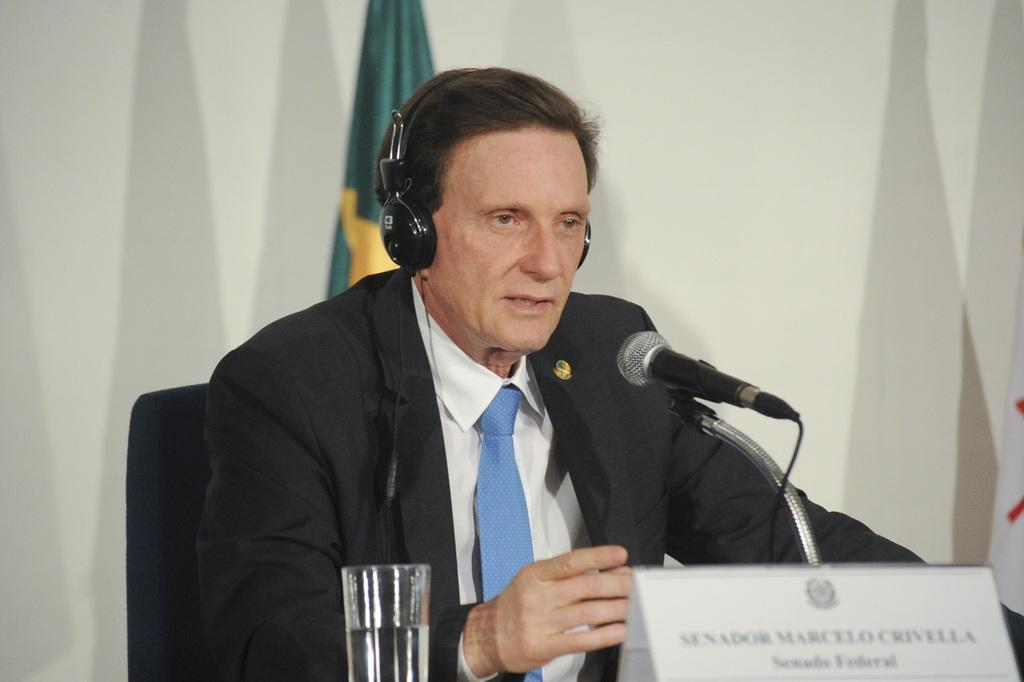Could you give a brief overview of what you see in this image? In the picture I can see a man is sitting on a chair and wearing headphones over the head. Here I can see a microphone, a glass and a board on which there is something written on it. In the background I can see a flag and a white color wall. 